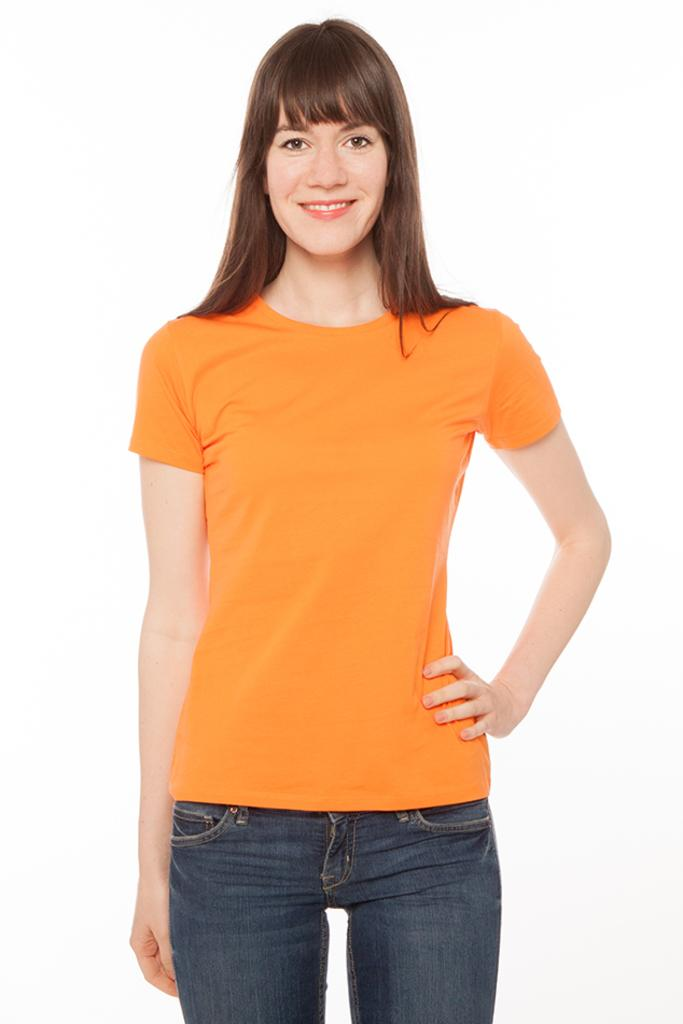Who or what is the main subject of the image? There is a person in the image. What is the person wearing? The person is wearing a black and orange dress. What color is the background of the image? The background of the image is white. What type of rail can be seen in the image? There is no rail present in the image. How does the person in the image show their approval? The image does not show the person expressing approval or disapproval, so it cannot be determined from the image. 